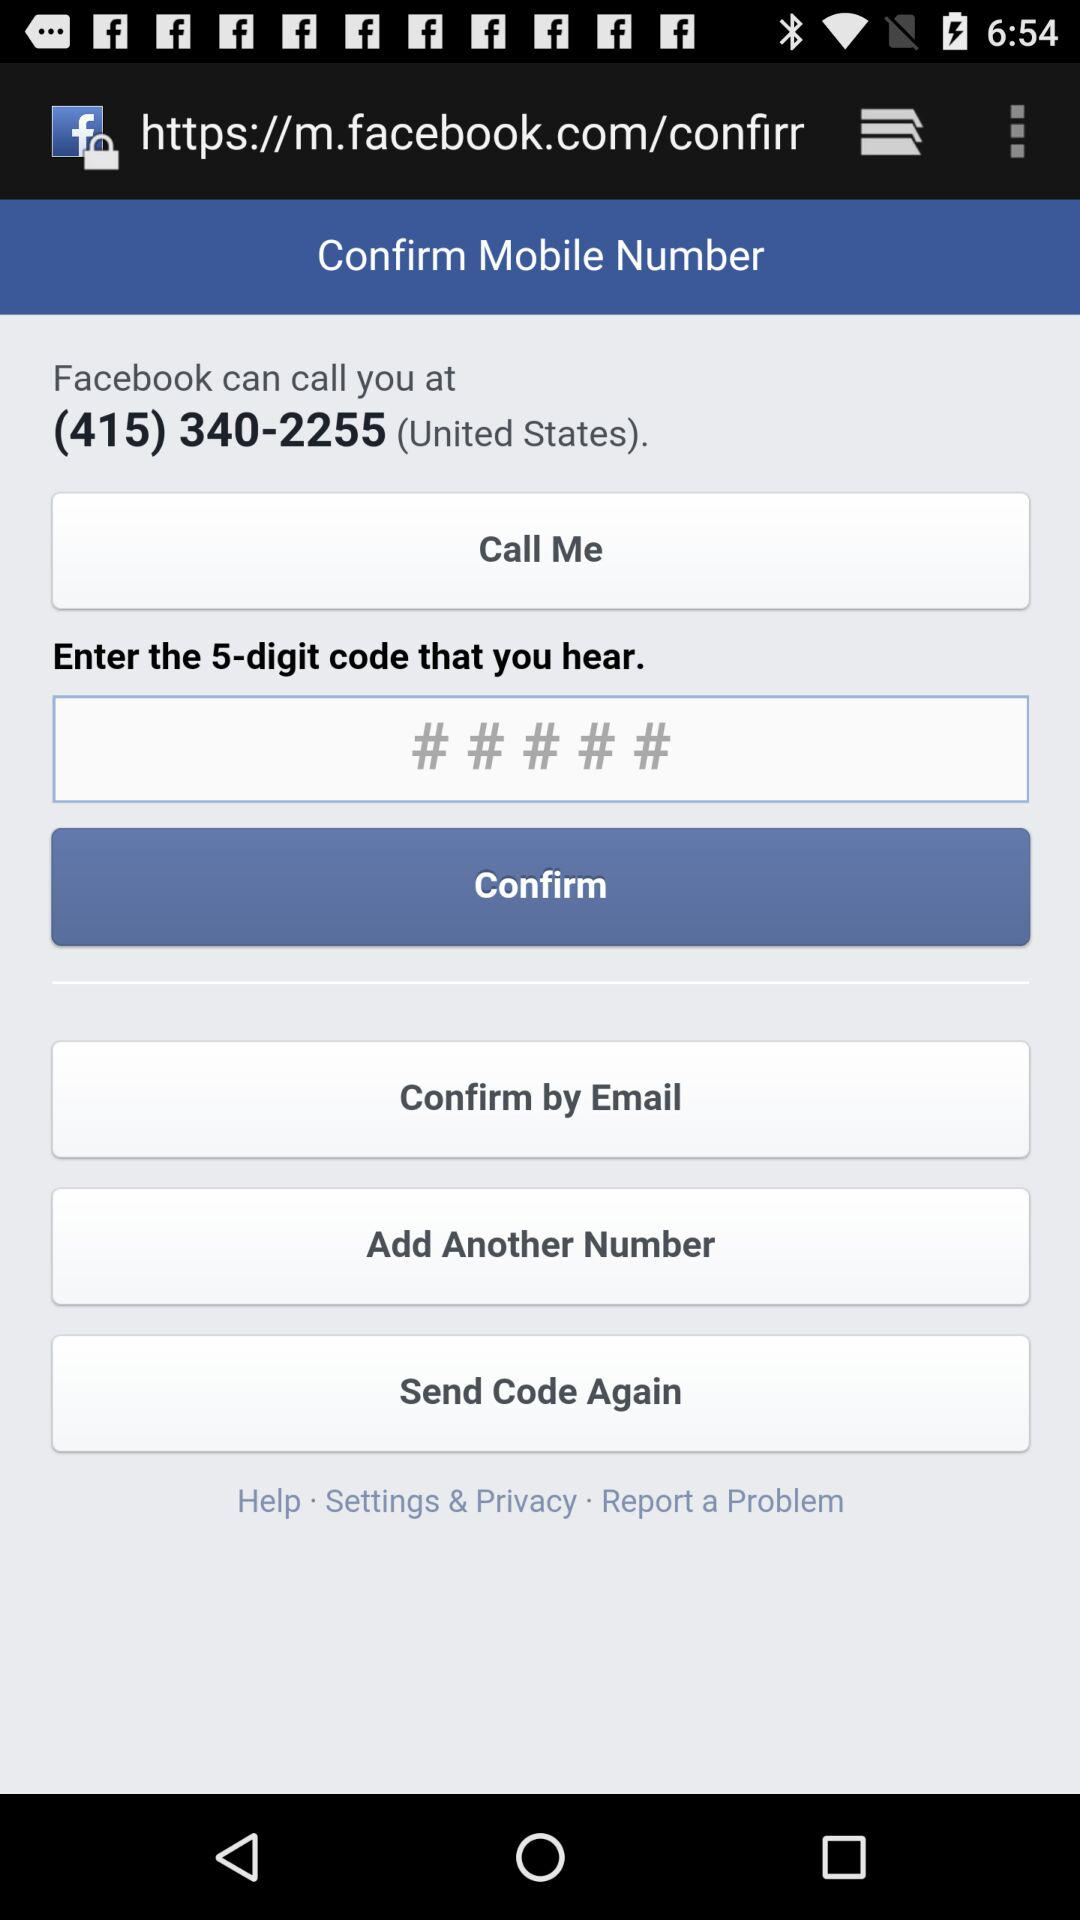What's the phone number? The phone number is (415) 340-2255. 